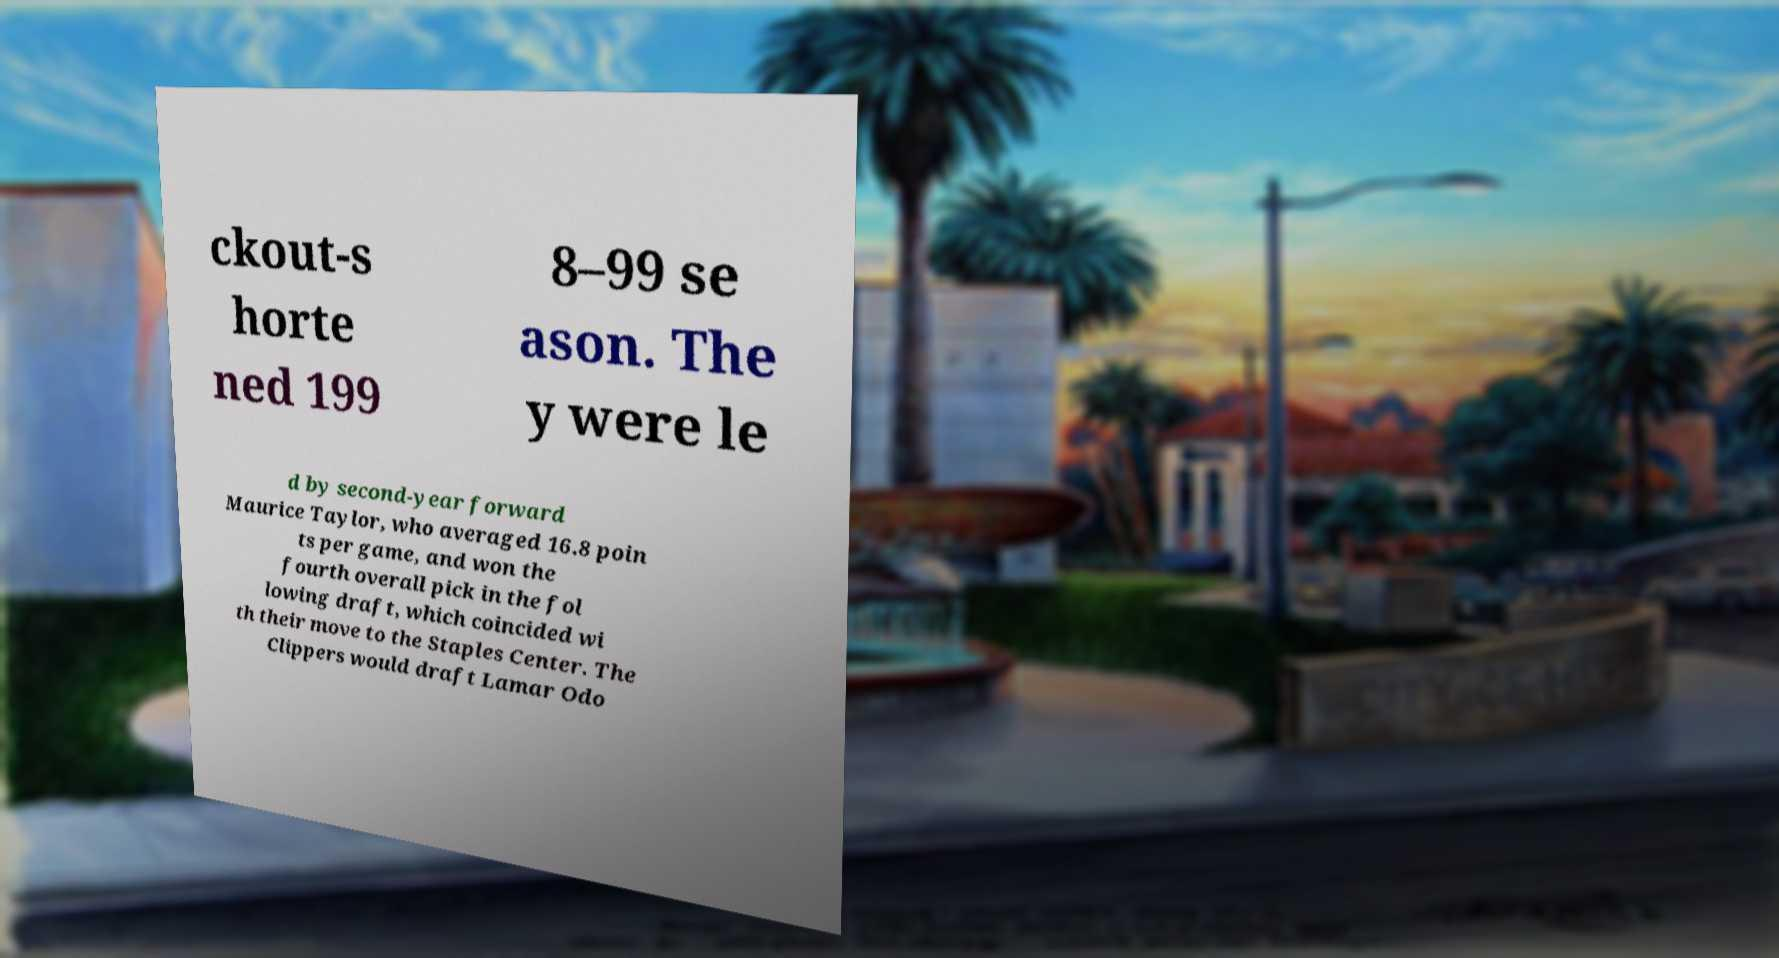Could you extract and type out the text from this image? ckout-s horte ned 199 8–99 se ason. The y were le d by second-year forward Maurice Taylor, who averaged 16.8 poin ts per game, and won the fourth overall pick in the fol lowing draft, which coincided wi th their move to the Staples Center. The Clippers would draft Lamar Odo 